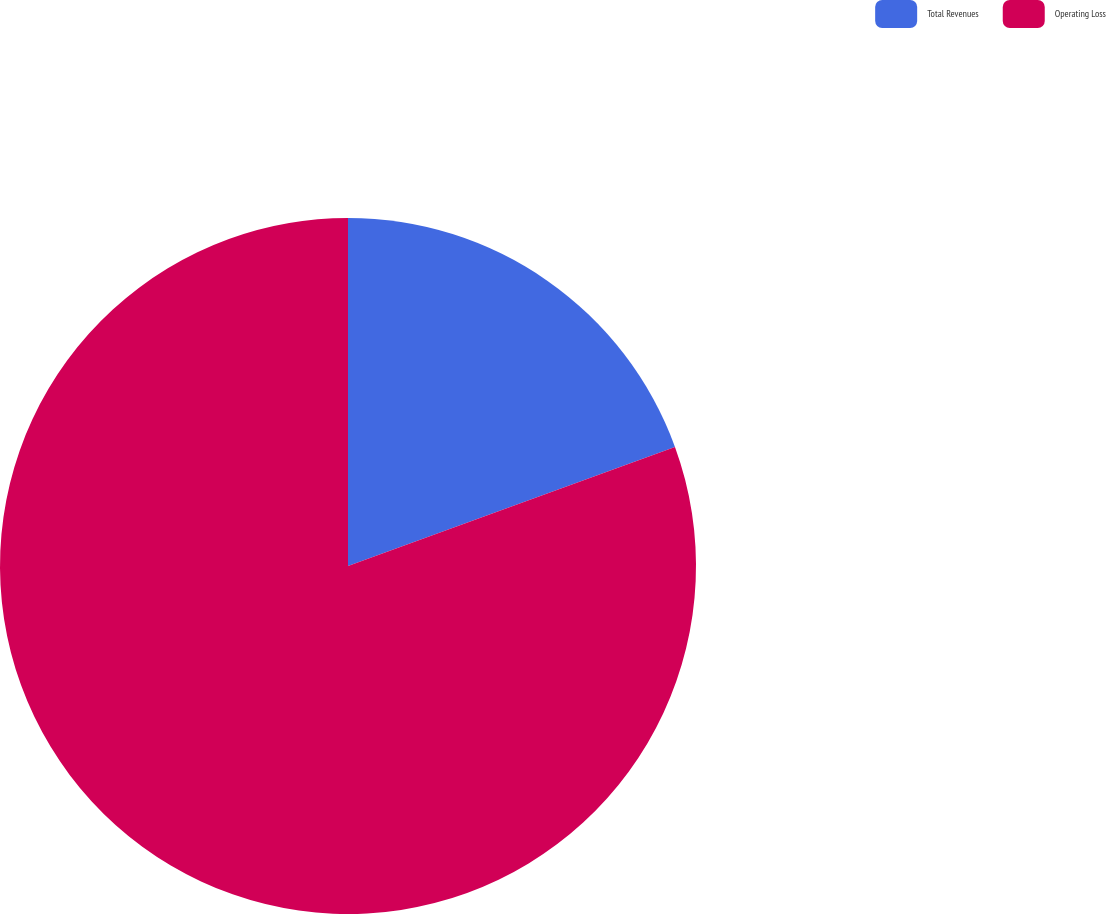<chart> <loc_0><loc_0><loc_500><loc_500><pie_chart><fcel>Total Revenues<fcel>Operating Loss<nl><fcel>19.44%<fcel>80.56%<nl></chart> 